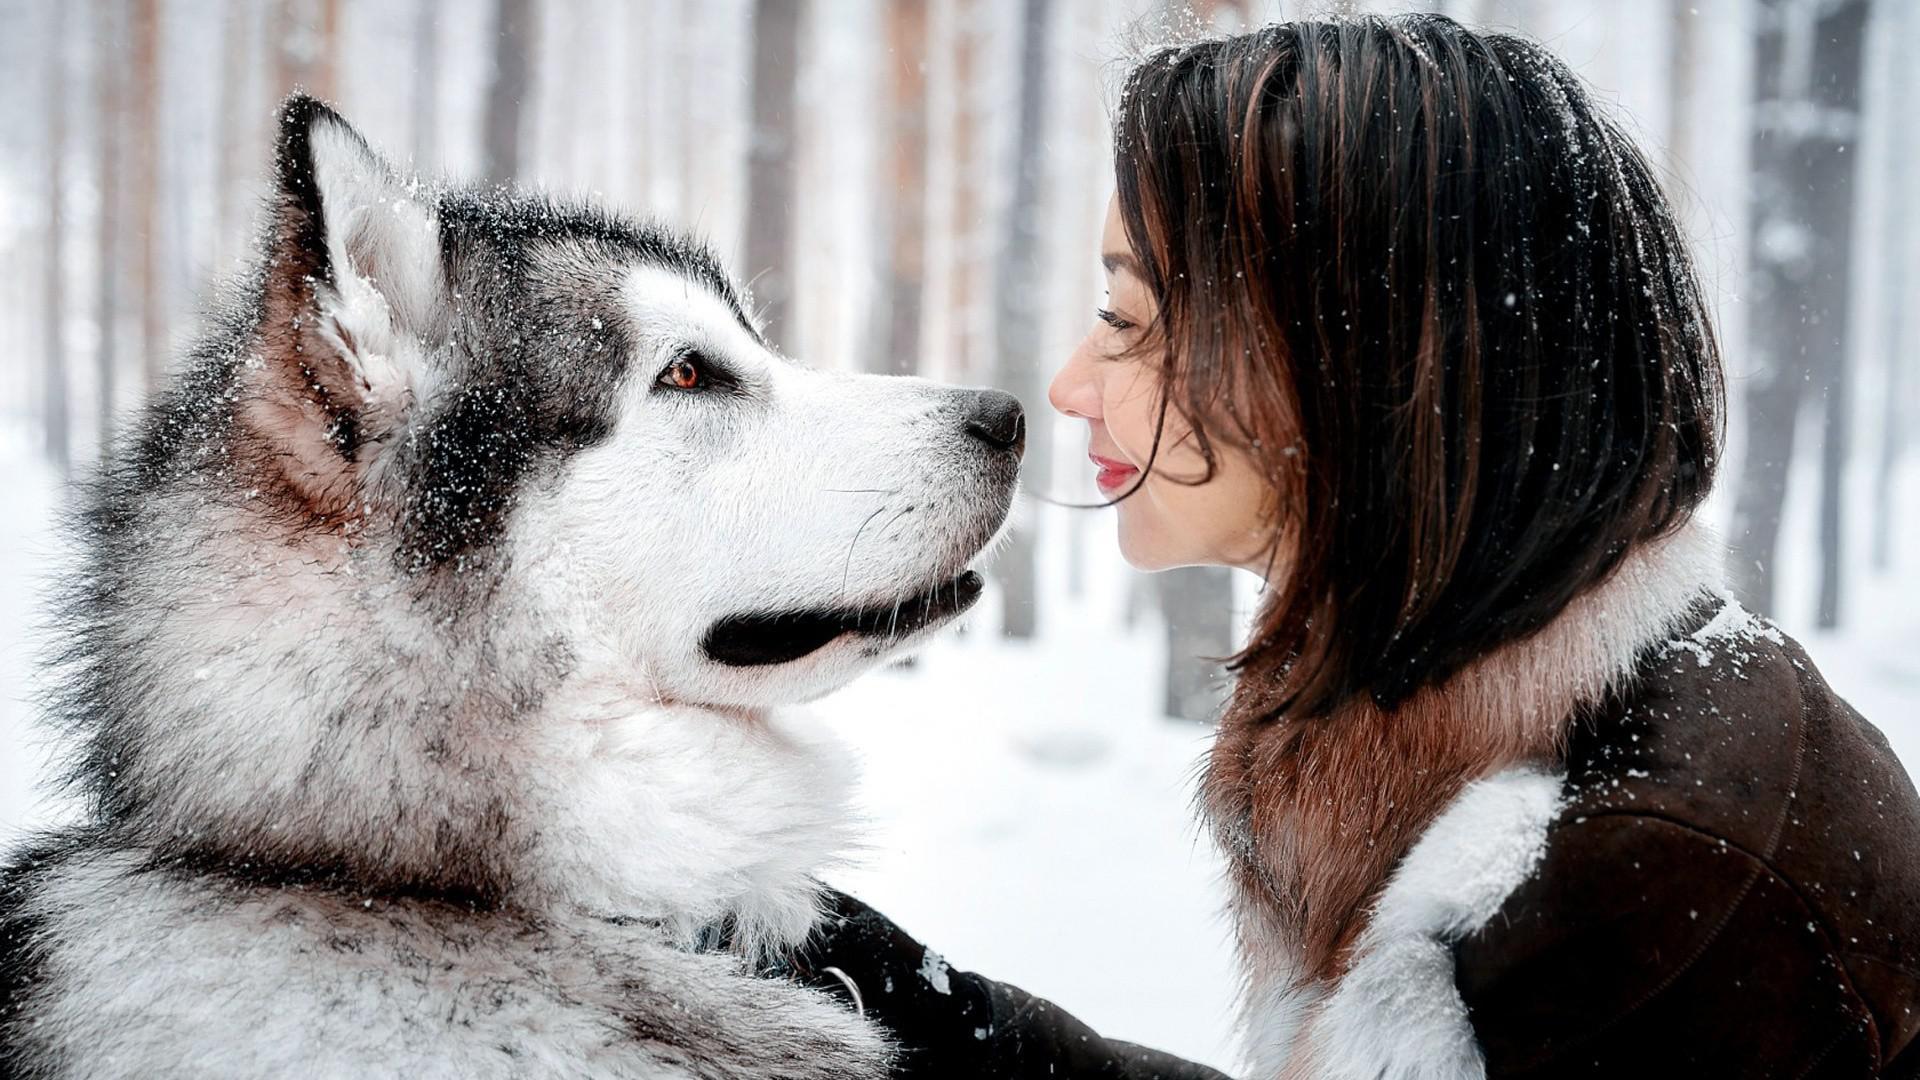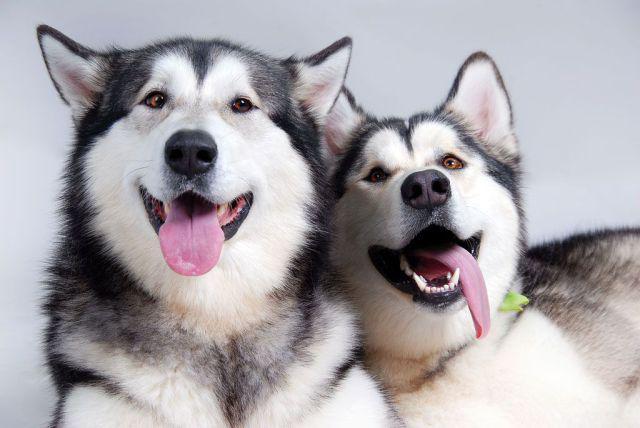The first image is the image on the left, the second image is the image on the right. For the images shown, is this caption "In one image, at least one dog has its mouth open, and in the other image, no dogs have their mouth open." true? Answer yes or no. Yes. The first image is the image on the left, the second image is the image on the right. For the images displayed, is the sentence "The left image shows a smaller black-and-tan spaniel sitting to the left of a taller black-and-white sitting husky with open mouth and upright ears." factually correct? Answer yes or no. No. 